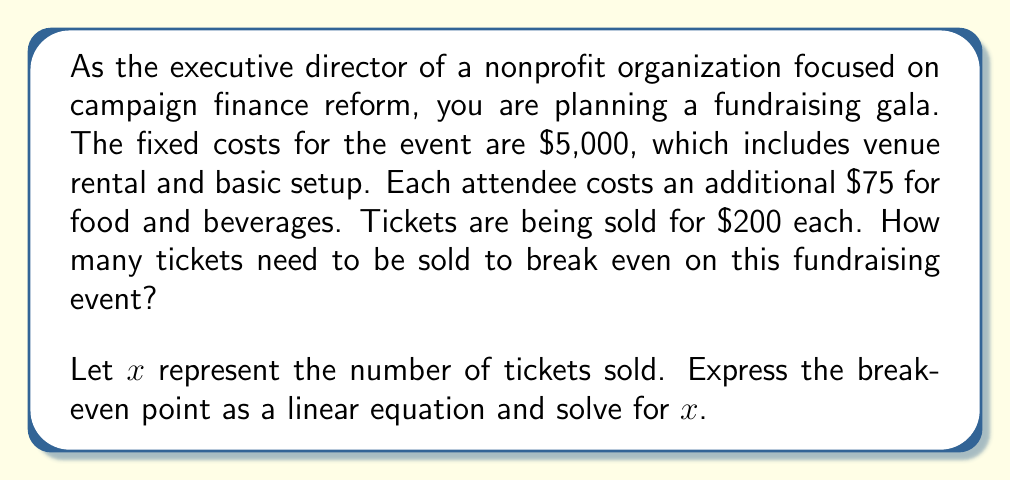Show me your answer to this math problem. To solve this problem, we need to set up a linear equation where the total revenue equals the total costs. This is the break-even point.

1. Let's define our variables:
   $x$ = number of tickets sold
   
2. Express the total revenue:
   Revenue = $200x$ (ticket price multiplied by number of tickets)

3. Express the total costs:
   Costs = $5000 + 75x$ (fixed costs plus variable cost per attendee multiplied by number of attendees)

4. Set up the break-even equation:
   Revenue = Costs
   $200x = 5000 + 75x$

5. Solve for $x$:
   $200x - 75x = 5000$
   $125x = 5000$
   $x = 5000 \div 125 = 40$

Therefore, the linear equation representing the break-even point is:

$$ 200x = 5000 + 75x $$

Solving this equation gives us the number of tickets that need to be sold to break even.
Answer: The nonprofit needs to sell 40 tickets to break even on the fundraising gala. 